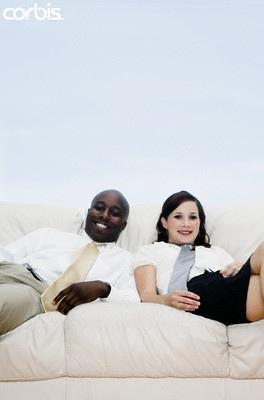How many black people?
Give a very brief answer. 1. How many people are visible?
Give a very brief answer. 2. 